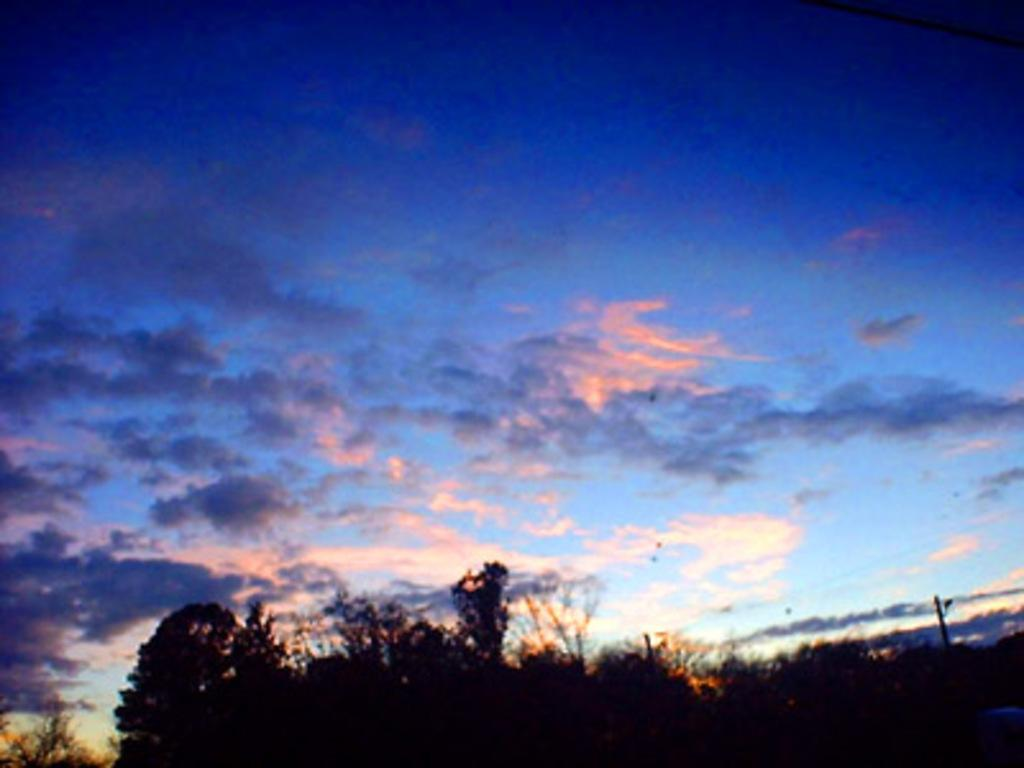What type of vegetation is at the bottom of the image? There are trees at the bottom of the image. What is visible at the top of the image? The sky is visible at the top of the image. What object can be seen on the right side of the image? There is a pole on the right side of the image. What hobbies are the trees at the bottom of the image engaged in? Trees do not engage in hobbies, as they are inanimate objects. 